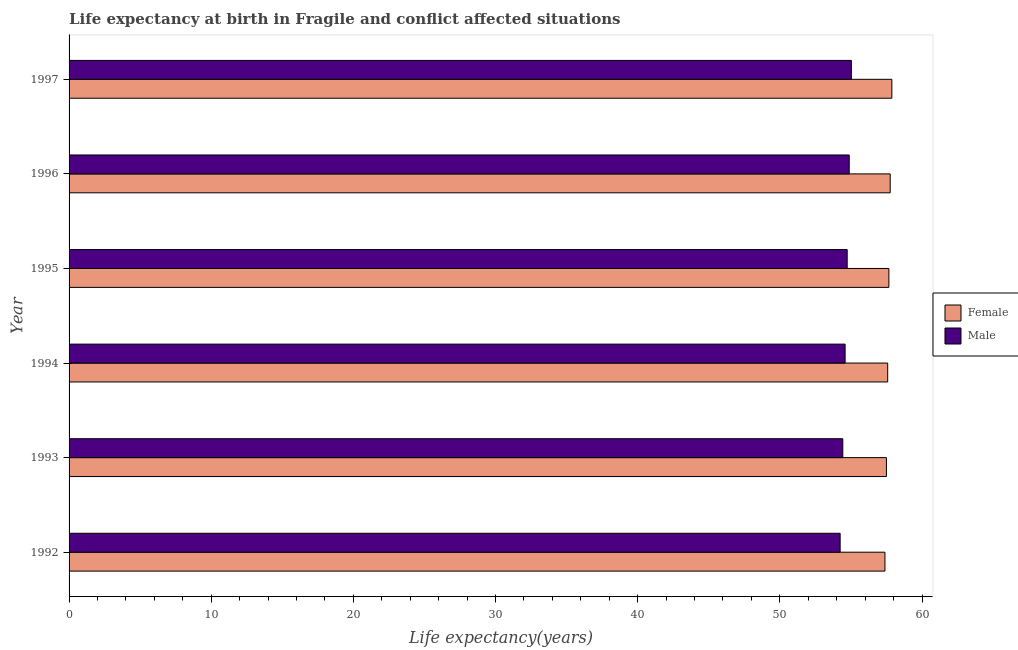How many different coloured bars are there?
Provide a short and direct response. 2. How many groups of bars are there?
Your answer should be very brief. 6. Are the number of bars per tick equal to the number of legend labels?
Make the answer very short. Yes. Are the number of bars on each tick of the Y-axis equal?
Provide a succinct answer. Yes. How many bars are there on the 6th tick from the top?
Your answer should be very brief. 2. How many bars are there on the 2nd tick from the bottom?
Offer a terse response. 2. In how many cases, is the number of bars for a given year not equal to the number of legend labels?
Offer a very short reply. 0. What is the life expectancy(male) in 1997?
Give a very brief answer. 55.03. Across all years, what is the maximum life expectancy(male)?
Give a very brief answer. 55.03. Across all years, what is the minimum life expectancy(male)?
Provide a short and direct response. 54.24. In which year was the life expectancy(male) maximum?
Ensure brevity in your answer.  1997. In which year was the life expectancy(male) minimum?
Keep it short and to the point. 1992. What is the total life expectancy(male) in the graph?
Make the answer very short. 327.91. What is the difference between the life expectancy(male) in 1992 and that in 1997?
Your response must be concise. -0.79. What is the difference between the life expectancy(male) in 1995 and the life expectancy(female) in 1994?
Offer a very short reply. -2.85. What is the average life expectancy(female) per year?
Offer a very short reply. 57.63. In the year 1995, what is the difference between the life expectancy(male) and life expectancy(female)?
Offer a very short reply. -2.93. What is the ratio of the life expectancy(female) in 1993 to that in 1995?
Give a very brief answer. 1. Is the difference between the life expectancy(male) in 1995 and 1997 greater than the difference between the life expectancy(female) in 1995 and 1997?
Your answer should be compact. No. What is the difference between the highest and the second highest life expectancy(male)?
Your response must be concise. 0.15. What is the difference between the highest and the lowest life expectancy(male)?
Provide a succinct answer. 0.79. In how many years, is the life expectancy(male) greater than the average life expectancy(male) taken over all years?
Keep it short and to the point. 3. Is the sum of the life expectancy(female) in 1992 and 1997 greater than the maximum life expectancy(male) across all years?
Make the answer very short. Yes. What does the 1st bar from the bottom in 1995 represents?
Provide a succinct answer. Female. How many bars are there?
Provide a short and direct response. 12. Are all the bars in the graph horizontal?
Make the answer very short. Yes. What is the difference between two consecutive major ticks on the X-axis?
Offer a terse response. 10. Does the graph contain any zero values?
Give a very brief answer. No. Does the graph contain grids?
Give a very brief answer. No. What is the title of the graph?
Provide a succinct answer. Life expectancy at birth in Fragile and conflict affected situations. What is the label or title of the X-axis?
Provide a succinct answer. Life expectancy(years). What is the Life expectancy(years) of Female in 1992?
Give a very brief answer. 57.39. What is the Life expectancy(years) in Male in 1992?
Ensure brevity in your answer.  54.24. What is the Life expectancy(years) in Female in 1993?
Ensure brevity in your answer.  57.5. What is the Life expectancy(years) in Male in 1993?
Offer a terse response. 54.43. What is the Life expectancy(years) of Female in 1994?
Make the answer very short. 57.59. What is the Life expectancy(years) of Male in 1994?
Your answer should be compact. 54.59. What is the Life expectancy(years) of Female in 1995?
Ensure brevity in your answer.  57.67. What is the Life expectancy(years) in Male in 1995?
Give a very brief answer. 54.74. What is the Life expectancy(years) in Female in 1996?
Your response must be concise. 57.76. What is the Life expectancy(years) of Male in 1996?
Your answer should be very brief. 54.88. What is the Life expectancy(years) in Female in 1997?
Provide a short and direct response. 57.88. What is the Life expectancy(years) of Male in 1997?
Your response must be concise. 55.03. Across all years, what is the maximum Life expectancy(years) in Female?
Your answer should be very brief. 57.88. Across all years, what is the maximum Life expectancy(years) of Male?
Provide a short and direct response. 55.03. Across all years, what is the minimum Life expectancy(years) of Female?
Offer a terse response. 57.39. Across all years, what is the minimum Life expectancy(years) of Male?
Your response must be concise. 54.24. What is the total Life expectancy(years) of Female in the graph?
Offer a very short reply. 345.79. What is the total Life expectancy(years) in Male in the graph?
Give a very brief answer. 327.91. What is the difference between the Life expectancy(years) in Female in 1992 and that in 1993?
Make the answer very short. -0.1. What is the difference between the Life expectancy(years) of Male in 1992 and that in 1993?
Give a very brief answer. -0.19. What is the difference between the Life expectancy(years) in Female in 1992 and that in 1994?
Make the answer very short. -0.19. What is the difference between the Life expectancy(years) of Male in 1992 and that in 1994?
Your answer should be very brief. -0.35. What is the difference between the Life expectancy(years) of Female in 1992 and that in 1995?
Keep it short and to the point. -0.28. What is the difference between the Life expectancy(years) of Male in 1992 and that in 1995?
Give a very brief answer. -0.5. What is the difference between the Life expectancy(years) of Female in 1992 and that in 1996?
Keep it short and to the point. -0.37. What is the difference between the Life expectancy(years) of Male in 1992 and that in 1996?
Your answer should be compact. -0.64. What is the difference between the Life expectancy(years) of Female in 1992 and that in 1997?
Give a very brief answer. -0.48. What is the difference between the Life expectancy(years) in Male in 1992 and that in 1997?
Your answer should be compact. -0.79. What is the difference between the Life expectancy(years) of Female in 1993 and that in 1994?
Your answer should be compact. -0.09. What is the difference between the Life expectancy(years) in Male in 1993 and that in 1994?
Make the answer very short. -0.16. What is the difference between the Life expectancy(years) of Female in 1993 and that in 1995?
Your response must be concise. -0.17. What is the difference between the Life expectancy(years) in Male in 1993 and that in 1995?
Provide a succinct answer. -0.31. What is the difference between the Life expectancy(years) of Female in 1993 and that in 1996?
Give a very brief answer. -0.27. What is the difference between the Life expectancy(years) in Male in 1993 and that in 1996?
Provide a short and direct response. -0.45. What is the difference between the Life expectancy(years) in Female in 1993 and that in 1997?
Make the answer very short. -0.38. What is the difference between the Life expectancy(years) in Male in 1993 and that in 1997?
Ensure brevity in your answer.  -0.6. What is the difference between the Life expectancy(years) in Female in 1994 and that in 1995?
Keep it short and to the point. -0.08. What is the difference between the Life expectancy(years) in Male in 1994 and that in 1995?
Your response must be concise. -0.15. What is the difference between the Life expectancy(years) of Female in 1994 and that in 1996?
Ensure brevity in your answer.  -0.18. What is the difference between the Life expectancy(years) of Male in 1994 and that in 1996?
Your response must be concise. -0.29. What is the difference between the Life expectancy(years) in Female in 1994 and that in 1997?
Your answer should be compact. -0.29. What is the difference between the Life expectancy(years) of Male in 1994 and that in 1997?
Offer a very short reply. -0.44. What is the difference between the Life expectancy(years) of Female in 1995 and that in 1996?
Your response must be concise. -0.09. What is the difference between the Life expectancy(years) in Male in 1995 and that in 1996?
Offer a terse response. -0.14. What is the difference between the Life expectancy(years) of Female in 1995 and that in 1997?
Your answer should be very brief. -0.21. What is the difference between the Life expectancy(years) of Male in 1995 and that in 1997?
Your answer should be compact. -0.29. What is the difference between the Life expectancy(years) of Female in 1996 and that in 1997?
Provide a short and direct response. -0.11. What is the difference between the Life expectancy(years) in Male in 1996 and that in 1997?
Your response must be concise. -0.15. What is the difference between the Life expectancy(years) in Female in 1992 and the Life expectancy(years) in Male in 1993?
Your response must be concise. 2.97. What is the difference between the Life expectancy(years) in Female in 1992 and the Life expectancy(years) in Male in 1994?
Ensure brevity in your answer.  2.8. What is the difference between the Life expectancy(years) in Female in 1992 and the Life expectancy(years) in Male in 1995?
Offer a terse response. 2.66. What is the difference between the Life expectancy(years) of Female in 1992 and the Life expectancy(years) of Male in 1996?
Provide a succinct answer. 2.51. What is the difference between the Life expectancy(years) of Female in 1992 and the Life expectancy(years) of Male in 1997?
Keep it short and to the point. 2.36. What is the difference between the Life expectancy(years) of Female in 1993 and the Life expectancy(years) of Male in 1994?
Ensure brevity in your answer.  2.91. What is the difference between the Life expectancy(years) of Female in 1993 and the Life expectancy(years) of Male in 1995?
Your answer should be very brief. 2.76. What is the difference between the Life expectancy(years) of Female in 1993 and the Life expectancy(years) of Male in 1996?
Keep it short and to the point. 2.62. What is the difference between the Life expectancy(years) of Female in 1993 and the Life expectancy(years) of Male in 1997?
Offer a terse response. 2.47. What is the difference between the Life expectancy(years) of Female in 1994 and the Life expectancy(years) of Male in 1995?
Make the answer very short. 2.85. What is the difference between the Life expectancy(years) of Female in 1994 and the Life expectancy(years) of Male in 1996?
Keep it short and to the point. 2.71. What is the difference between the Life expectancy(years) of Female in 1994 and the Life expectancy(years) of Male in 1997?
Ensure brevity in your answer.  2.55. What is the difference between the Life expectancy(years) of Female in 1995 and the Life expectancy(years) of Male in 1996?
Ensure brevity in your answer.  2.79. What is the difference between the Life expectancy(years) of Female in 1995 and the Life expectancy(years) of Male in 1997?
Ensure brevity in your answer.  2.64. What is the difference between the Life expectancy(years) in Female in 1996 and the Life expectancy(years) in Male in 1997?
Your response must be concise. 2.73. What is the average Life expectancy(years) in Female per year?
Offer a very short reply. 57.63. What is the average Life expectancy(years) of Male per year?
Make the answer very short. 54.65. In the year 1992, what is the difference between the Life expectancy(years) in Female and Life expectancy(years) in Male?
Ensure brevity in your answer.  3.15. In the year 1993, what is the difference between the Life expectancy(years) of Female and Life expectancy(years) of Male?
Your answer should be very brief. 3.07. In the year 1994, what is the difference between the Life expectancy(years) in Female and Life expectancy(years) in Male?
Provide a short and direct response. 2.99. In the year 1995, what is the difference between the Life expectancy(years) of Female and Life expectancy(years) of Male?
Give a very brief answer. 2.93. In the year 1996, what is the difference between the Life expectancy(years) in Female and Life expectancy(years) in Male?
Offer a very short reply. 2.88. In the year 1997, what is the difference between the Life expectancy(years) in Female and Life expectancy(years) in Male?
Provide a short and direct response. 2.85. What is the ratio of the Life expectancy(years) in Female in 1992 to that in 1993?
Your answer should be very brief. 1. What is the ratio of the Life expectancy(years) in Female in 1992 to that in 1994?
Make the answer very short. 1. What is the ratio of the Life expectancy(years) in Male in 1992 to that in 1995?
Make the answer very short. 0.99. What is the ratio of the Life expectancy(years) in Male in 1992 to that in 1996?
Ensure brevity in your answer.  0.99. What is the ratio of the Life expectancy(years) in Female in 1992 to that in 1997?
Your answer should be very brief. 0.99. What is the ratio of the Life expectancy(years) of Male in 1992 to that in 1997?
Offer a terse response. 0.99. What is the ratio of the Life expectancy(years) of Female in 1993 to that in 1994?
Provide a short and direct response. 1. What is the ratio of the Life expectancy(years) of Male in 1993 to that in 1994?
Your response must be concise. 1. What is the ratio of the Life expectancy(years) in Female in 1993 to that in 1997?
Give a very brief answer. 0.99. What is the ratio of the Life expectancy(years) of Male in 1993 to that in 1997?
Offer a very short reply. 0.99. What is the ratio of the Life expectancy(years) in Male in 1994 to that in 1995?
Provide a succinct answer. 1. What is the ratio of the Life expectancy(years) of Female in 1995 to that in 1996?
Keep it short and to the point. 1. What is the ratio of the Life expectancy(years) of Male in 1995 to that in 1996?
Provide a short and direct response. 1. What is the ratio of the Life expectancy(years) of Female in 1995 to that in 1997?
Keep it short and to the point. 1. What is the ratio of the Life expectancy(years) in Male in 1995 to that in 1997?
Ensure brevity in your answer.  0.99. What is the ratio of the Life expectancy(years) in Female in 1996 to that in 1997?
Your answer should be compact. 1. What is the difference between the highest and the second highest Life expectancy(years) in Female?
Make the answer very short. 0.11. What is the difference between the highest and the second highest Life expectancy(years) in Male?
Your answer should be very brief. 0.15. What is the difference between the highest and the lowest Life expectancy(years) of Female?
Offer a terse response. 0.48. What is the difference between the highest and the lowest Life expectancy(years) in Male?
Offer a very short reply. 0.79. 